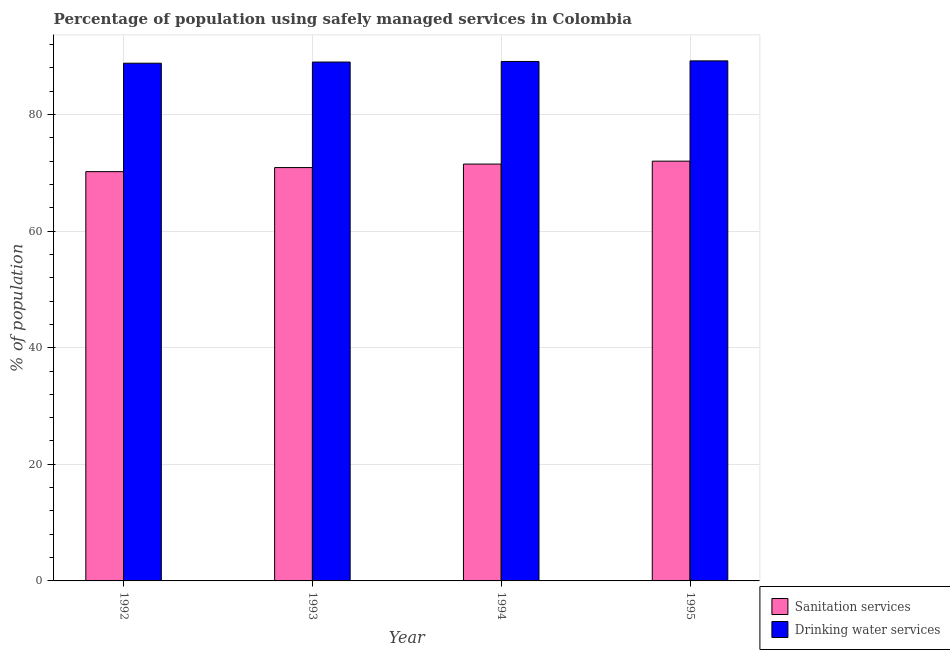Are the number of bars on each tick of the X-axis equal?
Make the answer very short. Yes. How many bars are there on the 4th tick from the right?
Ensure brevity in your answer.  2. What is the label of the 4th group of bars from the left?
Give a very brief answer. 1995. In how many cases, is the number of bars for a given year not equal to the number of legend labels?
Give a very brief answer. 0. What is the percentage of population who used drinking water services in 1993?
Your response must be concise. 89. Across all years, what is the maximum percentage of population who used drinking water services?
Your answer should be compact. 89.2. Across all years, what is the minimum percentage of population who used drinking water services?
Provide a succinct answer. 88.8. In which year was the percentage of population who used drinking water services maximum?
Your response must be concise. 1995. In which year was the percentage of population who used sanitation services minimum?
Ensure brevity in your answer.  1992. What is the total percentage of population who used drinking water services in the graph?
Your answer should be very brief. 356.1. What is the difference between the percentage of population who used drinking water services in 1992 and that in 1993?
Make the answer very short. -0.2. What is the difference between the percentage of population who used drinking water services in 1994 and the percentage of population who used sanitation services in 1995?
Offer a very short reply. -0.1. What is the average percentage of population who used drinking water services per year?
Provide a short and direct response. 89.02. In the year 1995, what is the difference between the percentage of population who used sanitation services and percentage of population who used drinking water services?
Keep it short and to the point. 0. What is the ratio of the percentage of population who used drinking water services in 1992 to that in 1994?
Your response must be concise. 1. Is the percentage of population who used sanitation services in 1992 less than that in 1993?
Your answer should be very brief. Yes. Is the difference between the percentage of population who used sanitation services in 1993 and 1994 greater than the difference between the percentage of population who used drinking water services in 1993 and 1994?
Your answer should be very brief. No. What is the difference between the highest and the second highest percentage of population who used drinking water services?
Provide a succinct answer. 0.1. What is the difference between the highest and the lowest percentage of population who used drinking water services?
Your answer should be very brief. 0.4. What does the 2nd bar from the left in 1993 represents?
Provide a short and direct response. Drinking water services. What does the 1st bar from the right in 1993 represents?
Provide a succinct answer. Drinking water services. How many years are there in the graph?
Give a very brief answer. 4. What is the difference between two consecutive major ticks on the Y-axis?
Give a very brief answer. 20. Does the graph contain any zero values?
Your answer should be compact. No. Does the graph contain grids?
Your response must be concise. Yes. How many legend labels are there?
Keep it short and to the point. 2. How are the legend labels stacked?
Ensure brevity in your answer.  Vertical. What is the title of the graph?
Ensure brevity in your answer.  Percentage of population using safely managed services in Colombia. Does "Overweight" appear as one of the legend labels in the graph?
Your answer should be compact. No. What is the label or title of the Y-axis?
Provide a short and direct response. % of population. What is the % of population in Sanitation services in 1992?
Your answer should be very brief. 70.2. What is the % of population in Drinking water services in 1992?
Your answer should be compact. 88.8. What is the % of population in Sanitation services in 1993?
Your answer should be very brief. 70.9. What is the % of population in Drinking water services in 1993?
Your answer should be compact. 89. What is the % of population of Sanitation services in 1994?
Offer a very short reply. 71.5. What is the % of population of Drinking water services in 1994?
Give a very brief answer. 89.1. What is the % of population of Sanitation services in 1995?
Keep it short and to the point. 72. What is the % of population in Drinking water services in 1995?
Provide a short and direct response. 89.2. Across all years, what is the maximum % of population of Drinking water services?
Offer a terse response. 89.2. Across all years, what is the minimum % of population of Sanitation services?
Offer a terse response. 70.2. Across all years, what is the minimum % of population of Drinking water services?
Your response must be concise. 88.8. What is the total % of population of Sanitation services in the graph?
Ensure brevity in your answer.  284.6. What is the total % of population of Drinking water services in the graph?
Your answer should be compact. 356.1. What is the difference between the % of population in Drinking water services in 1992 and that in 1994?
Your response must be concise. -0.3. What is the difference between the % of population in Sanitation services in 1992 and that in 1995?
Your answer should be very brief. -1.8. What is the difference between the % of population in Sanitation services in 1993 and that in 1995?
Keep it short and to the point. -1.1. What is the difference between the % of population of Drinking water services in 1994 and that in 1995?
Keep it short and to the point. -0.1. What is the difference between the % of population of Sanitation services in 1992 and the % of population of Drinking water services in 1993?
Give a very brief answer. -18.8. What is the difference between the % of population of Sanitation services in 1992 and the % of population of Drinking water services in 1994?
Provide a succinct answer. -18.9. What is the difference between the % of population in Sanitation services in 1993 and the % of population in Drinking water services in 1994?
Provide a succinct answer. -18.2. What is the difference between the % of population in Sanitation services in 1993 and the % of population in Drinking water services in 1995?
Your answer should be very brief. -18.3. What is the difference between the % of population of Sanitation services in 1994 and the % of population of Drinking water services in 1995?
Offer a terse response. -17.7. What is the average % of population of Sanitation services per year?
Give a very brief answer. 71.15. What is the average % of population in Drinking water services per year?
Offer a terse response. 89.03. In the year 1992, what is the difference between the % of population of Sanitation services and % of population of Drinking water services?
Keep it short and to the point. -18.6. In the year 1993, what is the difference between the % of population in Sanitation services and % of population in Drinking water services?
Provide a short and direct response. -18.1. In the year 1994, what is the difference between the % of population in Sanitation services and % of population in Drinking water services?
Offer a terse response. -17.6. In the year 1995, what is the difference between the % of population of Sanitation services and % of population of Drinking water services?
Offer a very short reply. -17.2. What is the ratio of the % of population in Sanitation services in 1992 to that in 1993?
Your answer should be very brief. 0.99. What is the ratio of the % of population of Drinking water services in 1992 to that in 1993?
Give a very brief answer. 1. What is the ratio of the % of population of Sanitation services in 1992 to that in 1994?
Your answer should be compact. 0.98. What is the ratio of the % of population of Sanitation services in 1992 to that in 1995?
Keep it short and to the point. 0.97. What is the ratio of the % of population of Drinking water services in 1993 to that in 1994?
Your answer should be compact. 1. What is the ratio of the % of population in Sanitation services in 1993 to that in 1995?
Your answer should be compact. 0.98. What is the ratio of the % of population in Drinking water services in 1993 to that in 1995?
Make the answer very short. 1. What is the ratio of the % of population in Sanitation services in 1994 to that in 1995?
Your answer should be very brief. 0.99. What is the difference between the highest and the second highest % of population of Sanitation services?
Offer a terse response. 0.5. What is the difference between the highest and the second highest % of population in Drinking water services?
Provide a short and direct response. 0.1. 